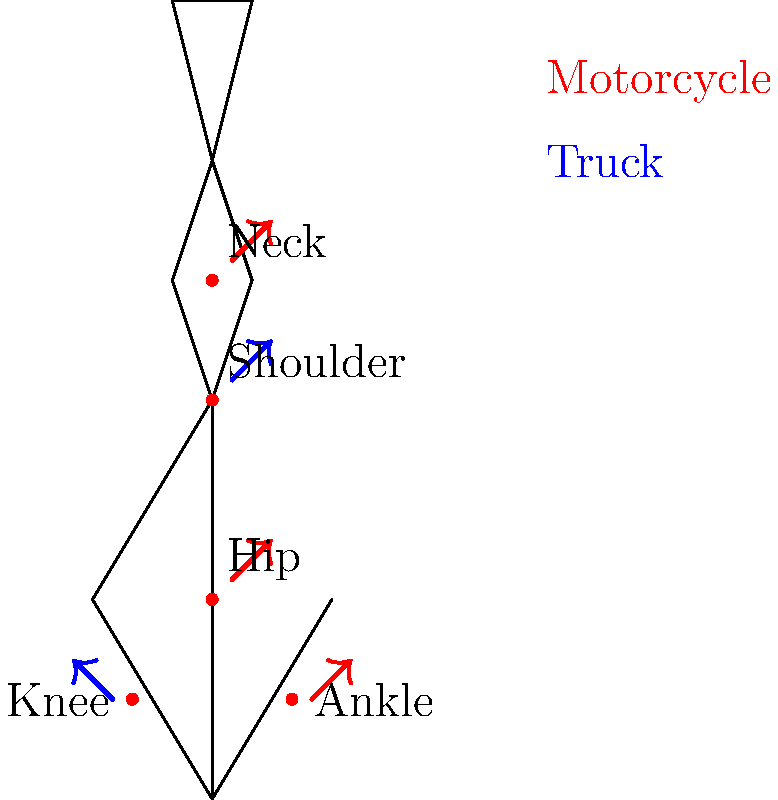Based on the diagram showing impact forces on different joints during motorcycle riding (red arrows) and truck driving (blue arrows), which joint experiences the most significant difference in force between the two activities, and why might this be the case? To answer this question, let's analyze the forces on each joint:

1. Neck: Both activities show significant force (red arrow for motorcycle).
2. Shoulder: Only truck driving shows a notable force (blue arrow).
3. Hip: Motorcycle riding shows a significant force (red arrow).
4. Knee: Only truck driving shows a notable force (blue arrow).
5. Ankle: Motorcycle riding shows a significant force (red arrow).

The most significant difference appears to be in the shoulder joint. Here's why:

1. During truck driving, the shoulder experiences constant stress from controlling the steering wheel and maintaining an upright posture for long periods.
2. In motorcycle riding, the shoulders are more relaxed and move freely with the body's natural movements.
3. The absence of a red arrow for the shoulder in motorcycle riding suggests minimal impact force compared to truck driving.
4. This difference is likely due to the contrasting body positions and control mechanisms between a truck and a motorcycle.

The hip and ankle also show differences, but the shoulder stands out as it transitions from a high-stress joint in truck driving to a low-stress joint in motorcycle riding.
Answer: Shoulder joint, due to contrasting body positions and control mechanisms. 